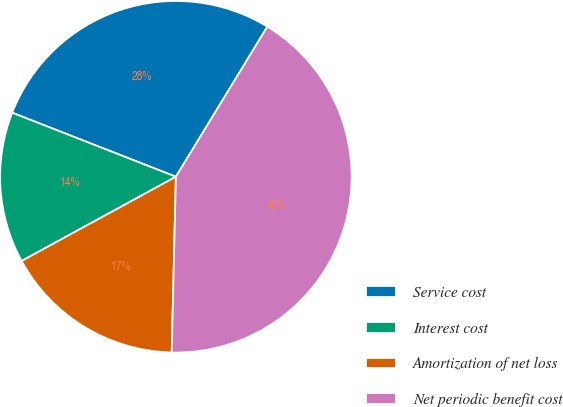<chart> <loc_0><loc_0><loc_500><loc_500><pie_chart><fcel>Service cost<fcel>Interest cost<fcel>Amortization of net loss<fcel>Net periodic benefit cost<nl><fcel>27.78%<fcel>13.89%<fcel>16.67%<fcel>41.67%<nl></chart> 